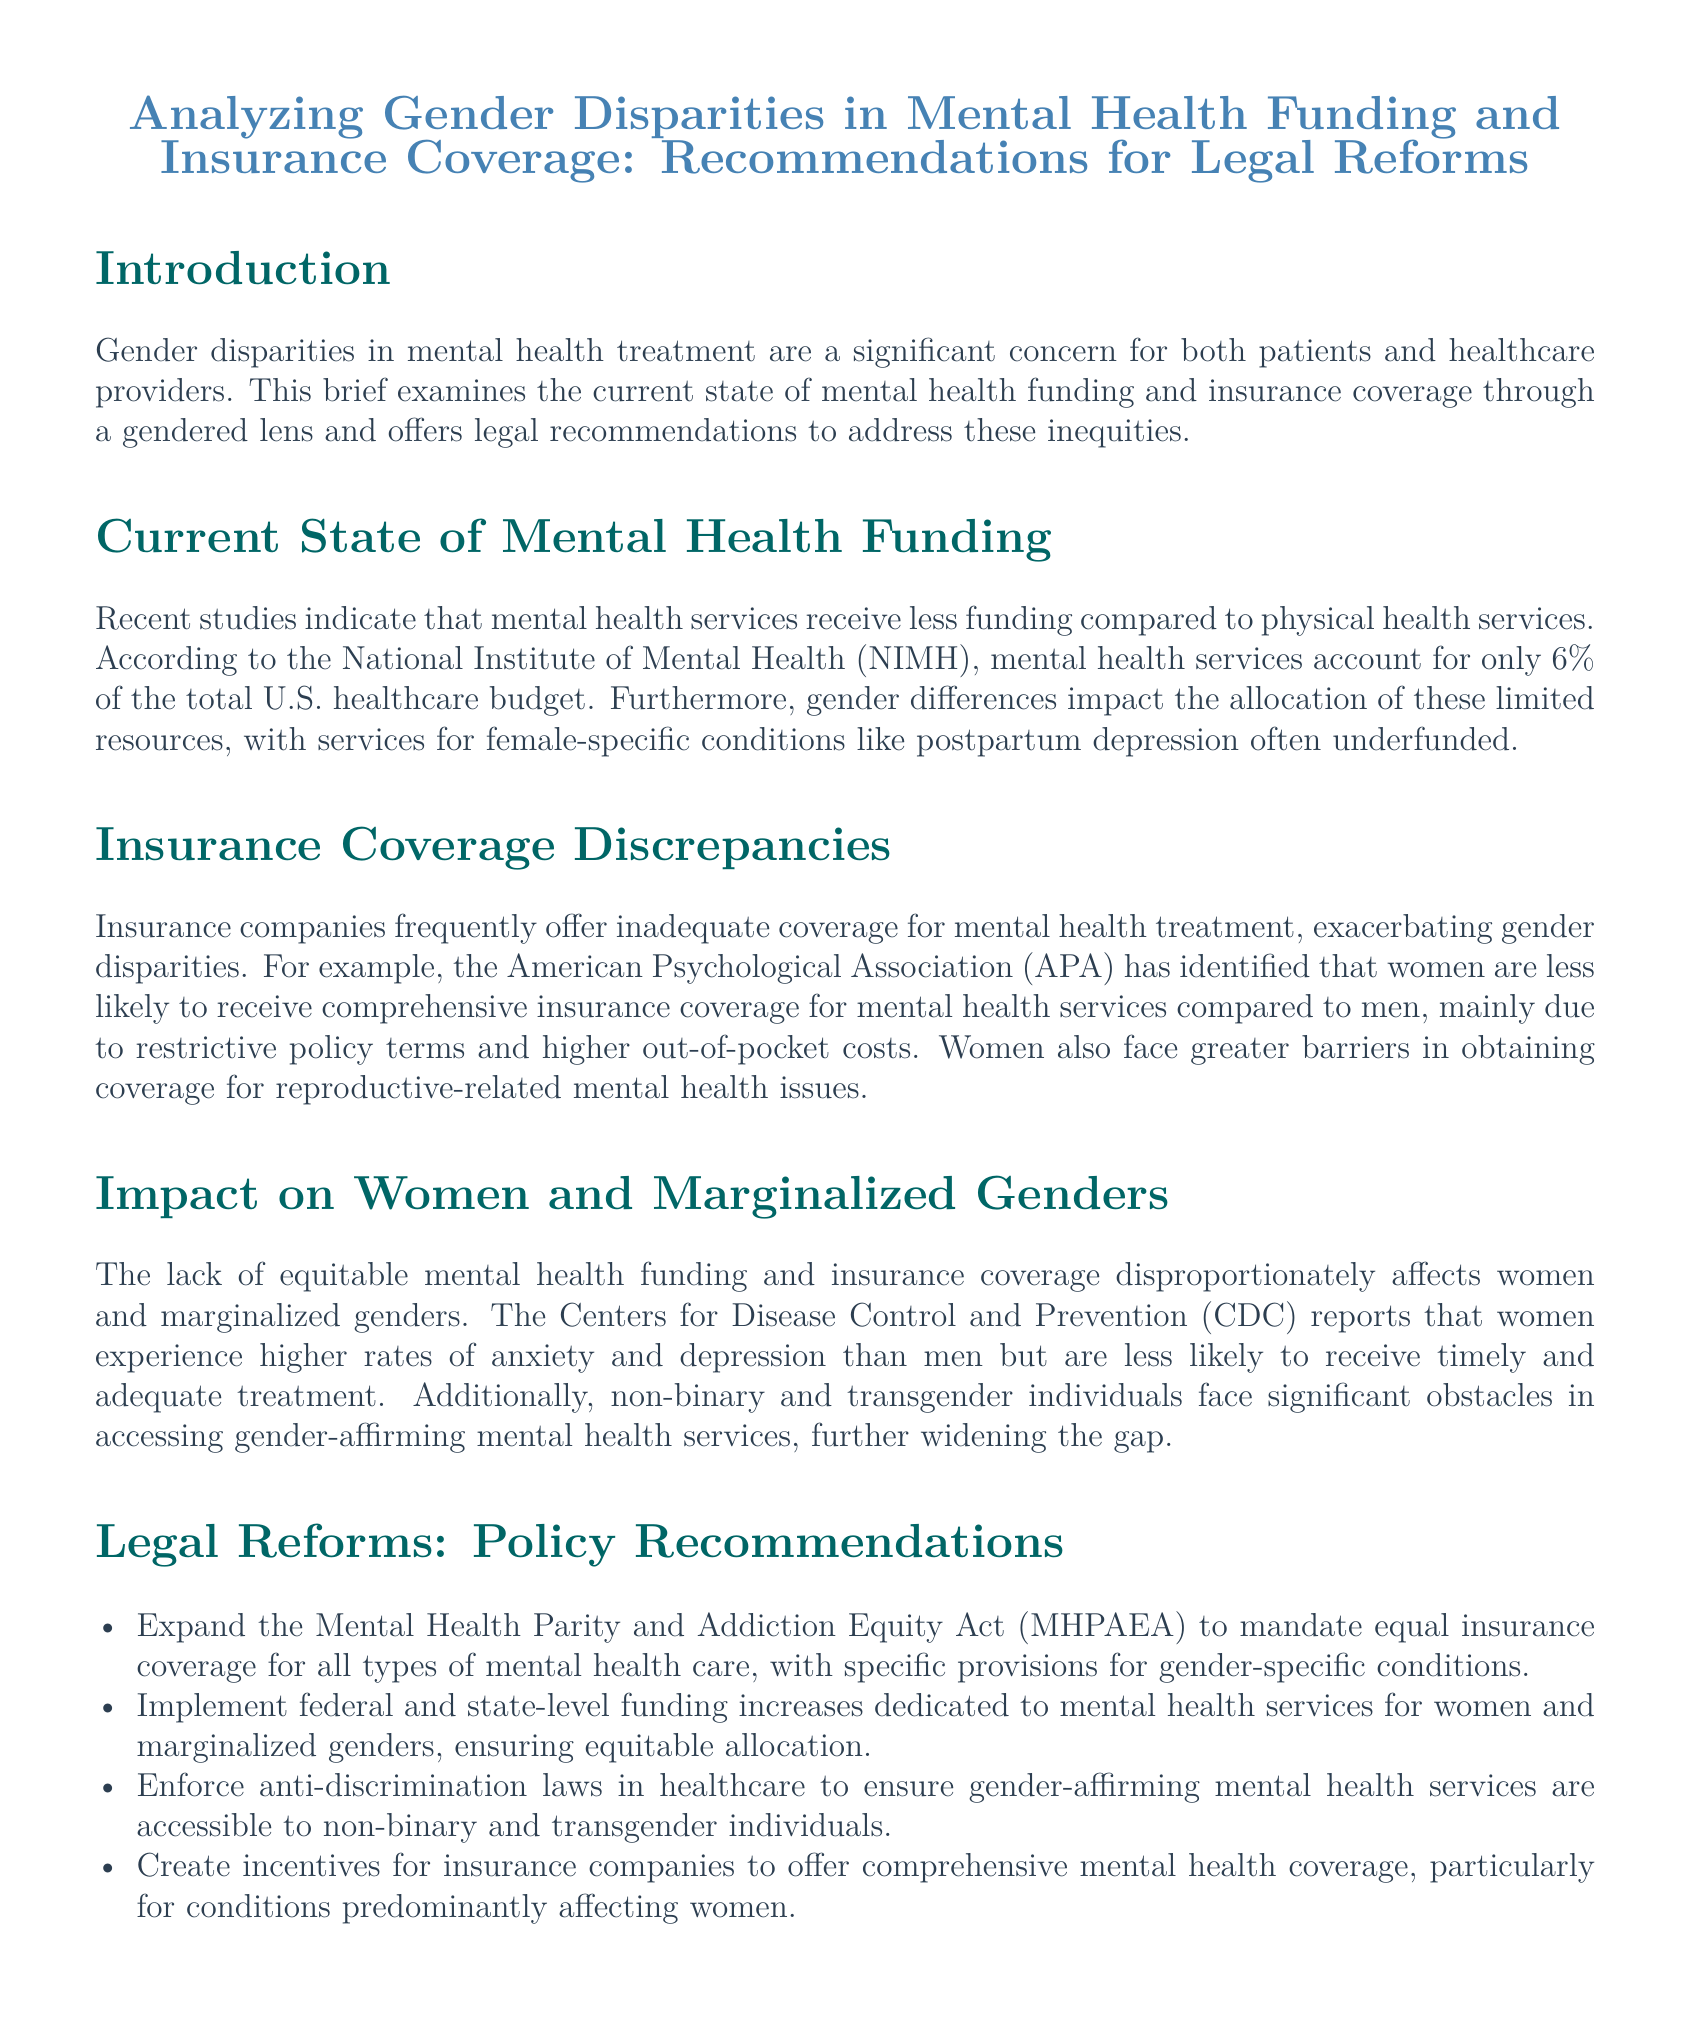What percentage of the U.S. healthcare budget is allocated to mental health services? The document states that mental health services account for only 6% of the total U.S. healthcare budget.
Answer: 6% What specific condition is mentioned as often underfunded? The brief highlights that services for female-specific conditions like postpartum depression are often underfunded.
Answer: postpartum depression Who experiences higher rates of anxiety and depression according to the CDC? The CDC reports that women experience higher rates of anxiety and depression than men.
Answer: women What act is recommended to be expanded for better mental health coverage? The document recommends expanding the Mental Health Parity and Addiction Equity Act (MHPAEA) for equal insurance coverage.
Answer: MHPAEA What type of individuals face significant obstacles in accessing gender-affirming mental health services? The brief specifies that non-binary and transgender individuals face significant obstacles in accessing gender-affirming mental health services.
Answer: non-binary and transgender individuals What is one of the main barriers for women in obtaining mental health coverage? The document states that women face higher out-of-pocket costs as a barrier to obtaining coverage.
Answer: higher out-of-pocket costs What does the brief suggest should be created to incentivize comprehensive mental health coverage? The document suggests creating incentives for insurance companies to offer comprehensive mental health coverage, particularly for conditions predominantly affecting women.
Answer: incentives Which organization identified inadequate coverage for women in mental health treatment? The American Psychological Association (APA) identified that women are less likely to receive comprehensive insurance coverage for mental health services.
Answer: American Psychological Association (APA) 